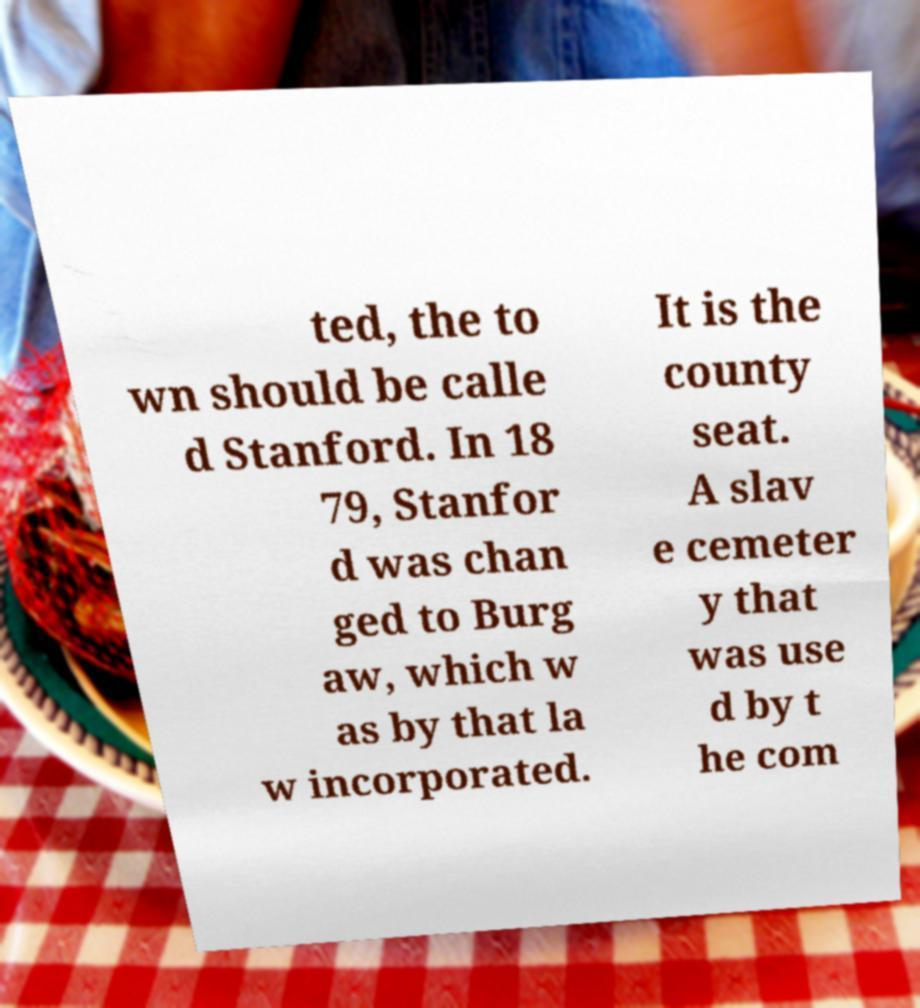Could you assist in decoding the text presented in this image and type it out clearly? ted, the to wn should be calle d Stanford. In 18 79, Stanfor d was chan ged to Burg aw, which w as by that la w incorporated. It is the county seat. A slav e cemeter y that was use d by t he com 